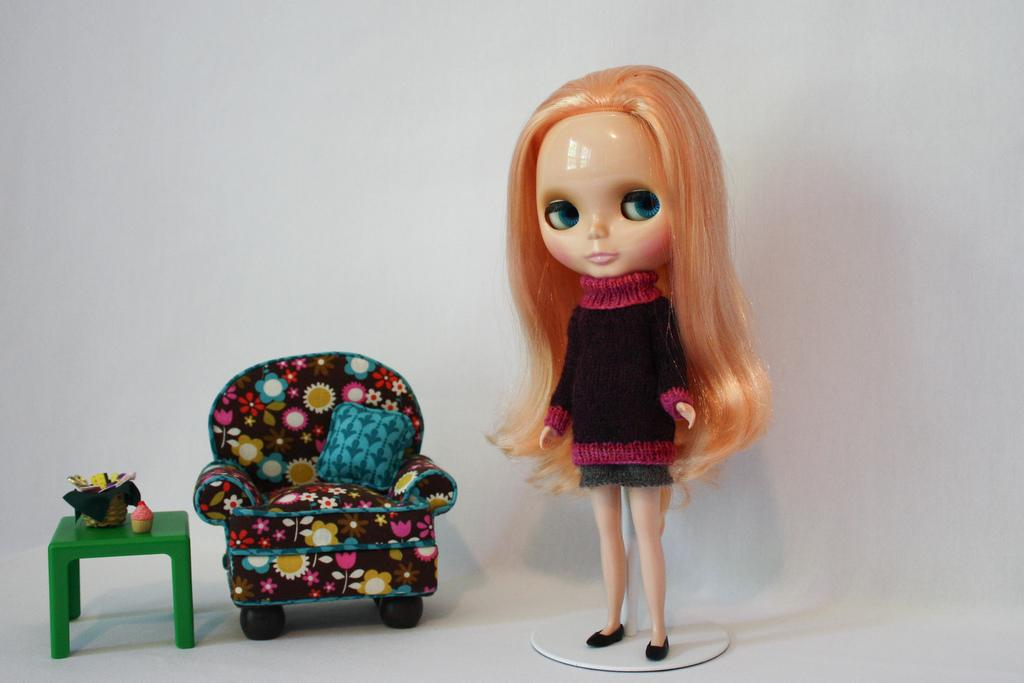What object is the main focus of the image? There is a doll in the image. What furniture is present in the image? There is a chair and a table in the image. What is on the table in the image? There is a cupcake and a basket on the table. What color is the background of the image? The background of the image is white. What type of coat is hanging on the doll in the image? There is no coat present in the image; the doll is not wearing or holding any clothing. What brand of soda can be seen in the image? There is no soda present in the image; only a cupcake and a basket are on the table. 